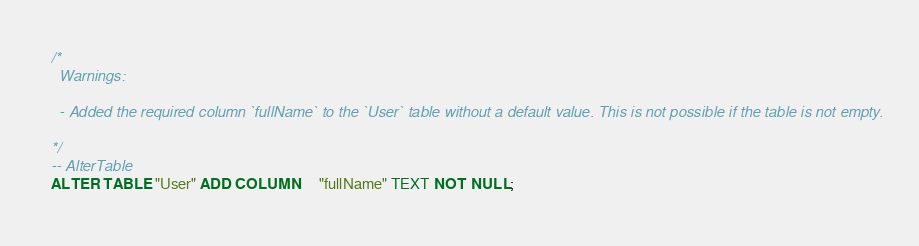Convert code to text. <code><loc_0><loc_0><loc_500><loc_500><_SQL_>/*
  Warnings:

  - Added the required column `fullName` to the `User` table without a default value. This is not possible if the table is not empty.

*/
-- AlterTable
ALTER TABLE "User" ADD COLUMN     "fullName" TEXT NOT NULL;
</code> 